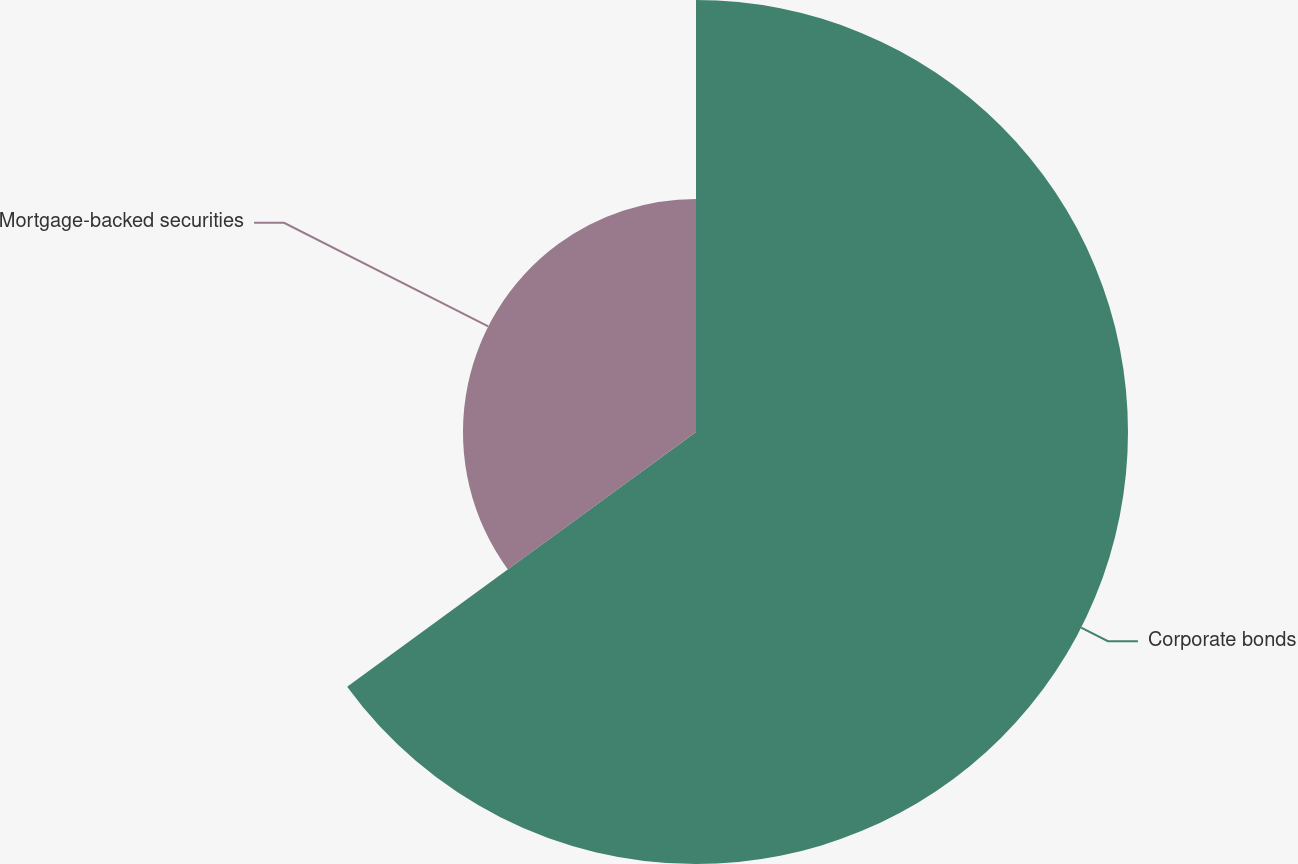Convert chart to OTSL. <chart><loc_0><loc_0><loc_500><loc_500><pie_chart><fcel>Corporate bonds<fcel>Mortgage-backed securities<nl><fcel>64.96%<fcel>35.04%<nl></chart> 